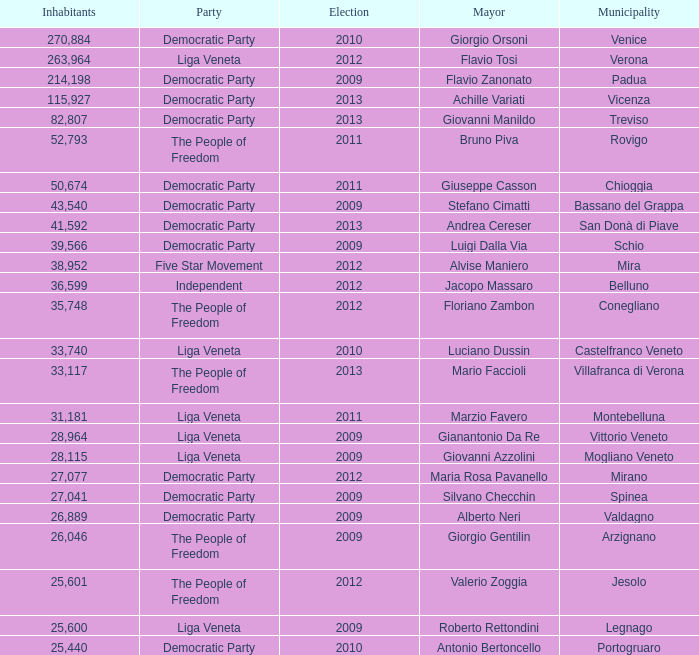Which political party was achille variati associated with? Democratic Party. 